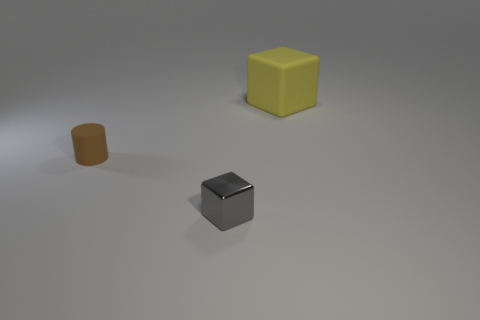Is there any other thing that is the same size as the yellow rubber thing?
Make the answer very short. No. What number of brown things are behind the thing in front of the small thing that is behind the gray metallic cube?
Your response must be concise. 1. What is the color of the thing on the right side of the tiny thing that is in front of the small rubber object?
Your response must be concise. Yellow. Are there any gray shiny cubes that have the same size as the yellow rubber object?
Provide a succinct answer. No. What is the material of the cube behind the small object that is in front of the rubber thing on the left side of the big yellow block?
Provide a succinct answer. Rubber. How many rubber objects are behind the matte object that is in front of the big yellow matte cube?
Provide a short and direct response. 1. Do the matte object in front of the yellow matte thing and the big block have the same size?
Offer a terse response. No. How many other small things are the same shape as the gray object?
Your response must be concise. 0. The large matte object has what shape?
Offer a terse response. Cube. Are there an equal number of matte cubes left of the small block and small brown things?
Provide a succinct answer. No. 